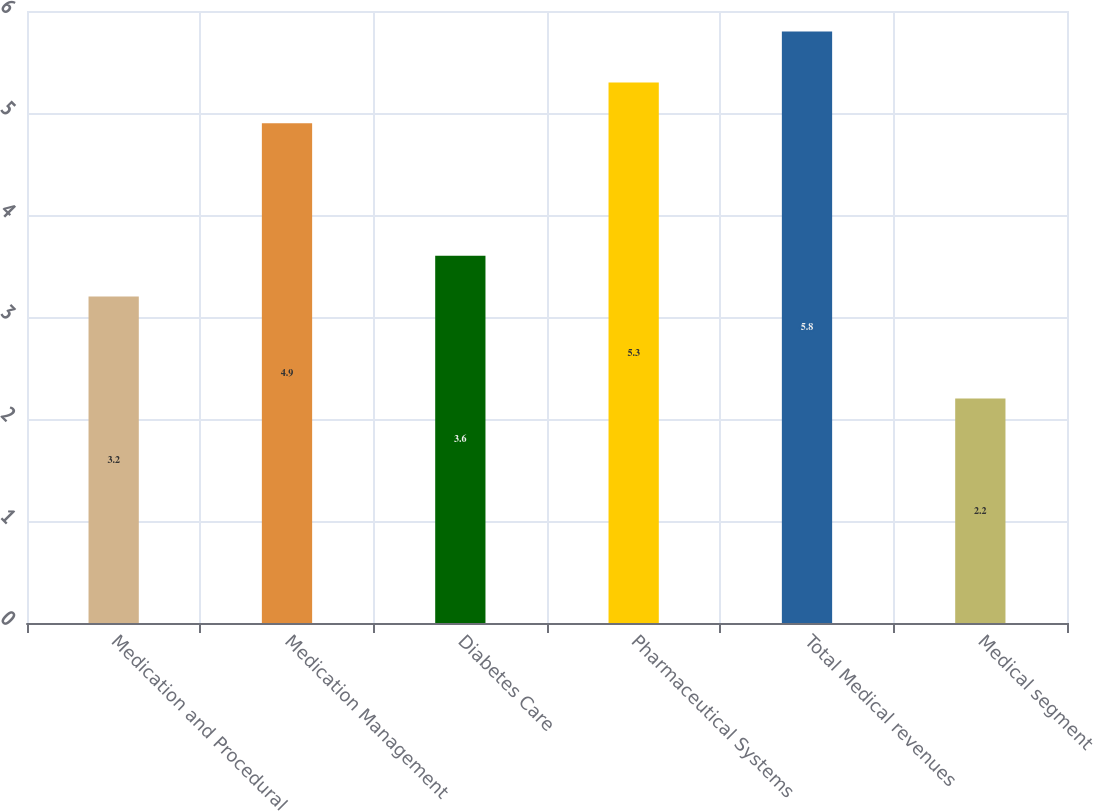Convert chart. <chart><loc_0><loc_0><loc_500><loc_500><bar_chart><fcel>Medication and Procedural<fcel>Medication Management<fcel>Diabetes Care<fcel>Pharmaceutical Systems<fcel>Total Medical revenues<fcel>Medical segment<nl><fcel>3.2<fcel>4.9<fcel>3.6<fcel>5.3<fcel>5.8<fcel>2.2<nl></chart> 